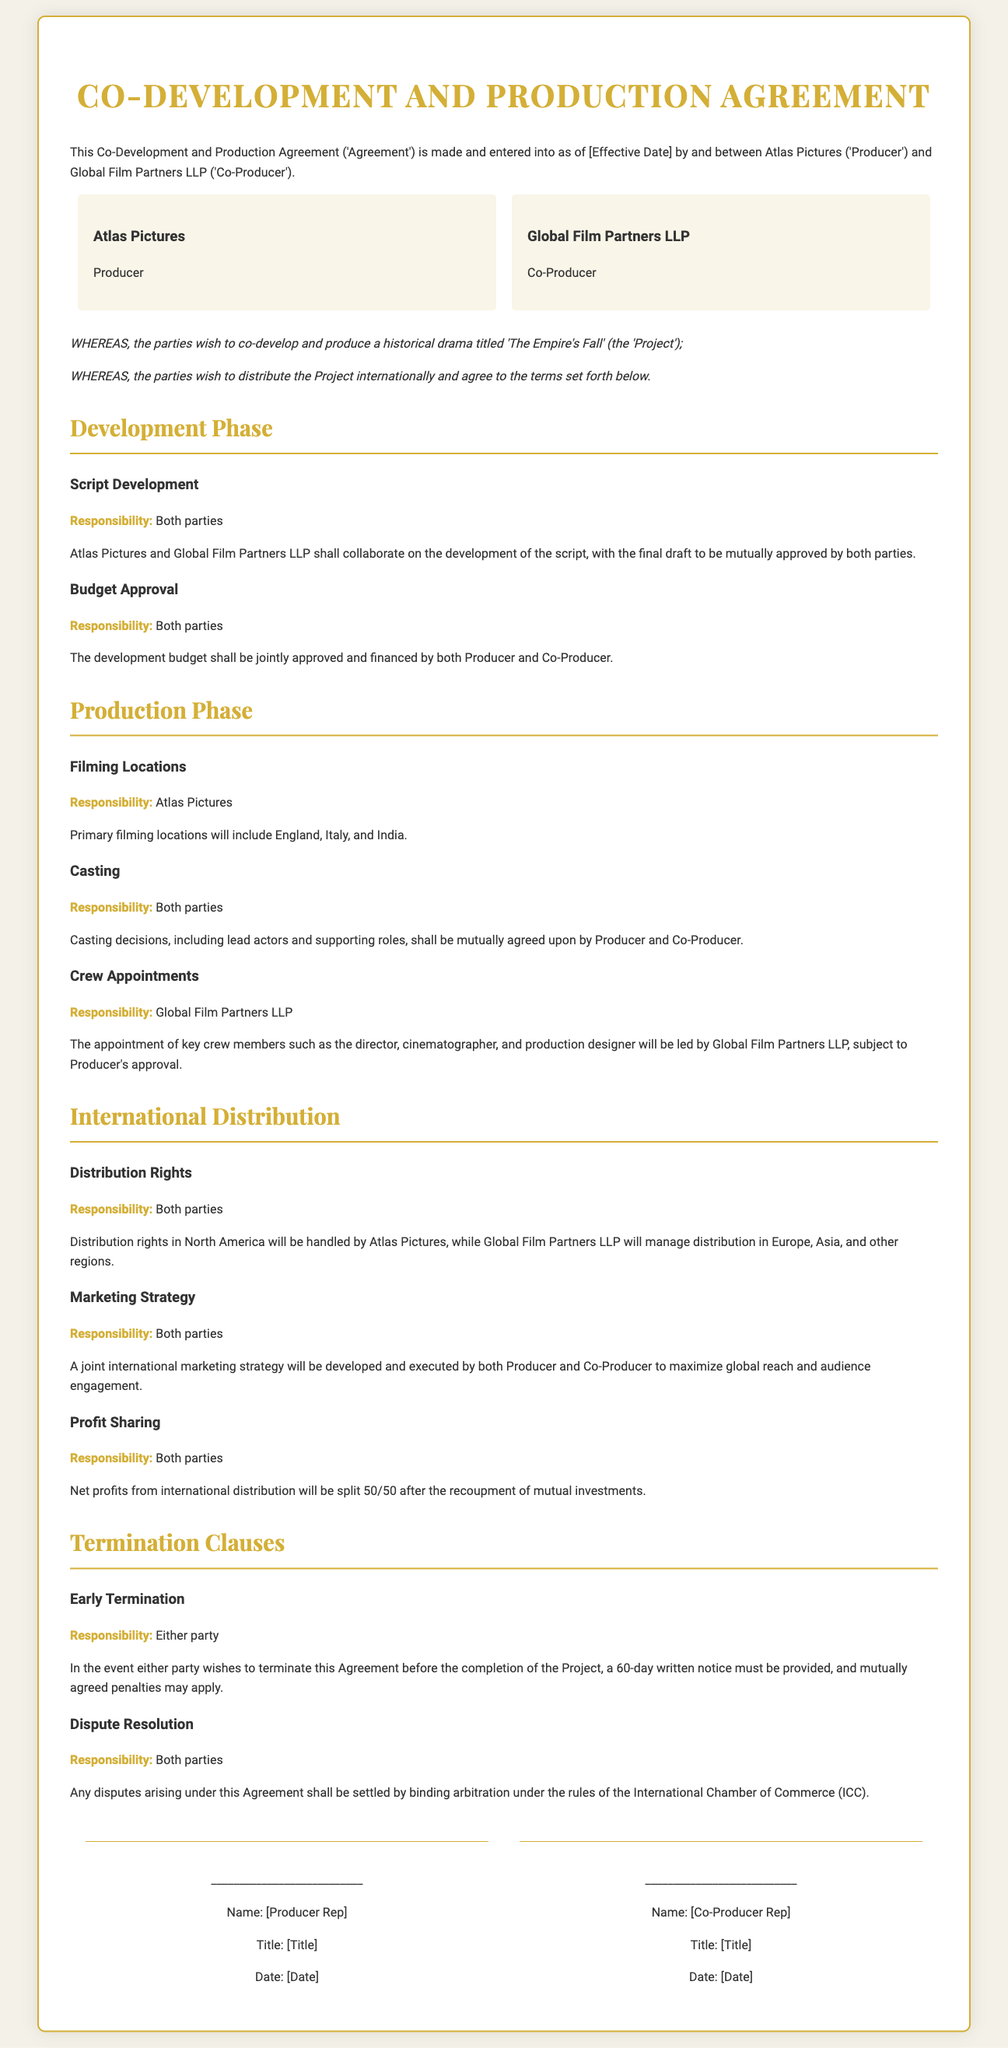What is the title of the Project? The title of the Project is mentioned in the recitals section of the document.
Answer: The Empire's Fall Who are the parties involved in this Agreement? The parties involved are identified at the beginning of the document.
Answer: Atlas Pictures and Global Film Partners LLP What is the primary filming location? The primary filming locations are specified under the Production Phase section.
Answer: England, Italy, and India How are the profits from international distribution split? The profit-sharing arrangement is detailed under the International Distribution section.
Answer: 50/50 What is the notice period for early termination? The notice period for early termination is stated in the Termination Clauses section.
Answer: 60 days Who is responsible for casting decisions? The responsibility for casting decisions is outlined under the Production Phase section.
Answer: Both parties Which body is referenced for dispute resolution? The dispute resolution method is specified in the Termination Clauses section.
Answer: International Chamber of Commerce (ICC) What type of project is this Agreement for? The nature of the project is outlined in the recitals section of the document.
Answer: Historical drama 